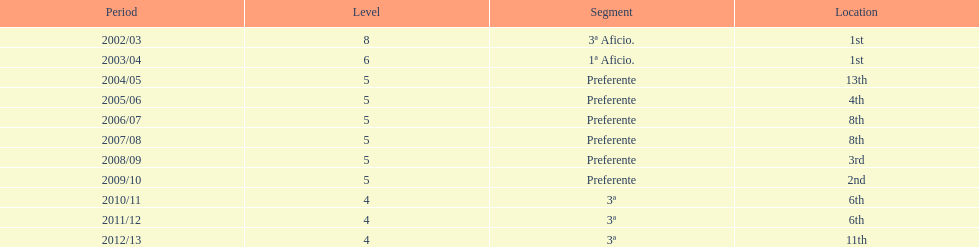How many times did internacional de madrid cf end the season at the top of their division? 2. 